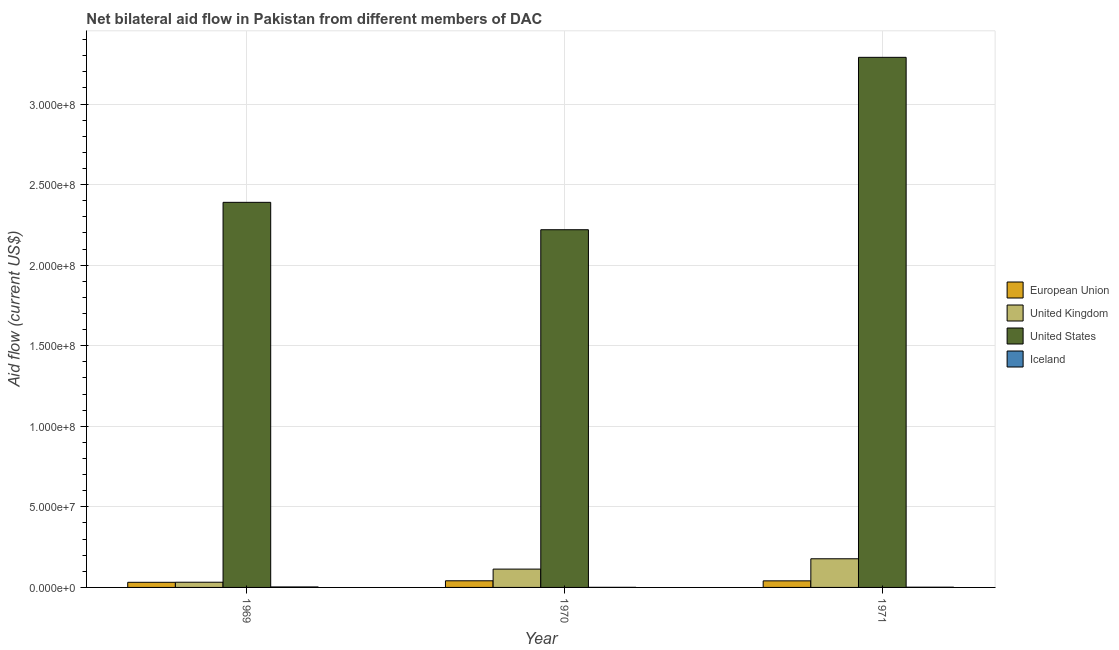How many groups of bars are there?
Offer a terse response. 3. Are the number of bars per tick equal to the number of legend labels?
Your answer should be very brief. Yes. How many bars are there on the 3rd tick from the left?
Give a very brief answer. 4. How many bars are there on the 3rd tick from the right?
Offer a very short reply. 4. What is the label of the 3rd group of bars from the left?
Your response must be concise. 1971. What is the amount of aid given by uk in 1971?
Provide a succinct answer. 1.78e+07. Across all years, what is the maximum amount of aid given by us?
Offer a very short reply. 3.29e+08. Across all years, what is the minimum amount of aid given by eu?
Ensure brevity in your answer.  3.18e+06. In which year was the amount of aid given by uk maximum?
Make the answer very short. 1971. In which year was the amount of aid given by uk minimum?
Keep it short and to the point. 1969. What is the total amount of aid given by us in the graph?
Offer a very short reply. 7.90e+08. What is the difference between the amount of aid given by uk in 1970 and that in 1971?
Provide a succinct answer. -6.41e+06. What is the difference between the amount of aid given by uk in 1971 and the amount of aid given by eu in 1969?
Offer a terse response. 1.46e+07. What is the average amount of aid given by eu per year?
Make the answer very short. 3.79e+06. In the year 1970, what is the difference between the amount of aid given by us and amount of aid given by uk?
Your answer should be compact. 0. What is the ratio of the amount of aid given by uk in 1970 to that in 1971?
Keep it short and to the point. 0.64. Is the amount of aid given by us in 1969 less than that in 1970?
Your answer should be compact. No. Is the difference between the amount of aid given by eu in 1969 and 1971 greater than the difference between the amount of aid given by us in 1969 and 1971?
Offer a terse response. No. What is the difference between the highest and the lowest amount of aid given by uk?
Your answer should be compact. 1.46e+07. In how many years, is the amount of aid given by eu greater than the average amount of aid given by eu taken over all years?
Your response must be concise. 2. Is it the case that in every year, the sum of the amount of aid given by us and amount of aid given by eu is greater than the sum of amount of aid given by uk and amount of aid given by iceland?
Offer a very short reply. Yes. Is it the case that in every year, the sum of the amount of aid given by eu and amount of aid given by uk is greater than the amount of aid given by us?
Your response must be concise. No. How many years are there in the graph?
Offer a very short reply. 3. Does the graph contain any zero values?
Offer a very short reply. No. Does the graph contain grids?
Your answer should be very brief. Yes. Where does the legend appear in the graph?
Provide a succinct answer. Center right. How many legend labels are there?
Offer a very short reply. 4. How are the legend labels stacked?
Provide a short and direct response. Vertical. What is the title of the graph?
Ensure brevity in your answer.  Net bilateral aid flow in Pakistan from different members of DAC. Does "Permission" appear as one of the legend labels in the graph?
Your answer should be very brief. No. What is the label or title of the Y-axis?
Your answer should be very brief. Aid flow (current US$). What is the Aid flow (current US$) of European Union in 1969?
Keep it short and to the point. 3.18e+06. What is the Aid flow (current US$) in United Kingdom in 1969?
Offer a very short reply. 3.23e+06. What is the Aid flow (current US$) in United States in 1969?
Keep it short and to the point. 2.39e+08. What is the Aid flow (current US$) of European Union in 1970?
Your answer should be very brief. 4.12e+06. What is the Aid flow (current US$) of United Kingdom in 1970?
Provide a succinct answer. 1.14e+07. What is the Aid flow (current US$) of United States in 1970?
Your answer should be very brief. 2.22e+08. What is the Aid flow (current US$) in Iceland in 1970?
Provide a succinct answer. 6.00e+04. What is the Aid flow (current US$) in European Union in 1971?
Offer a very short reply. 4.08e+06. What is the Aid flow (current US$) in United Kingdom in 1971?
Offer a very short reply. 1.78e+07. What is the Aid flow (current US$) in United States in 1971?
Provide a short and direct response. 3.29e+08. What is the Aid flow (current US$) of Iceland in 1971?
Provide a short and direct response. 1.40e+05. Across all years, what is the maximum Aid flow (current US$) of European Union?
Make the answer very short. 4.12e+06. Across all years, what is the maximum Aid flow (current US$) in United Kingdom?
Keep it short and to the point. 1.78e+07. Across all years, what is the maximum Aid flow (current US$) in United States?
Ensure brevity in your answer.  3.29e+08. Across all years, what is the maximum Aid flow (current US$) in Iceland?
Your answer should be compact. 3.00e+05. Across all years, what is the minimum Aid flow (current US$) of European Union?
Provide a succinct answer. 3.18e+06. Across all years, what is the minimum Aid flow (current US$) in United Kingdom?
Your response must be concise. 3.23e+06. Across all years, what is the minimum Aid flow (current US$) in United States?
Ensure brevity in your answer.  2.22e+08. Across all years, what is the minimum Aid flow (current US$) of Iceland?
Offer a terse response. 6.00e+04. What is the total Aid flow (current US$) in European Union in the graph?
Provide a succinct answer. 1.14e+07. What is the total Aid flow (current US$) in United Kingdom in the graph?
Your answer should be very brief. 3.24e+07. What is the total Aid flow (current US$) in United States in the graph?
Make the answer very short. 7.90e+08. What is the total Aid flow (current US$) in Iceland in the graph?
Provide a short and direct response. 5.00e+05. What is the difference between the Aid flow (current US$) in European Union in 1969 and that in 1970?
Keep it short and to the point. -9.40e+05. What is the difference between the Aid flow (current US$) of United Kingdom in 1969 and that in 1970?
Provide a short and direct response. -8.14e+06. What is the difference between the Aid flow (current US$) in United States in 1969 and that in 1970?
Provide a short and direct response. 1.70e+07. What is the difference between the Aid flow (current US$) of Iceland in 1969 and that in 1970?
Your response must be concise. 2.40e+05. What is the difference between the Aid flow (current US$) in European Union in 1969 and that in 1971?
Your answer should be compact. -9.00e+05. What is the difference between the Aid flow (current US$) in United Kingdom in 1969 and that in 1971?
Keep it short and to the point. -1.46e+07. What is the difference between the Aid flow (current US$) of United States in 1969 and that in 1971?
Provide a succinct answer. -9.00e+07. What is the difference between the Aid flow (current US$) in Iceland in 1969 and that in 1971?
Offer a terse response. 1.60e+05. What is the difference between the Aid flow (current US$) in United Kingdom in 1970 and that in 1971?
Keep it short and to the point. -6.41e+06. What is the difference between the Aid flow (current US$) of United States in 1970 and that in 1971?
Make the answer very short. -1.07e+08. What is the difference between the Aid flow (current US$) of Iceland in 1970 and that in 1971?
Your response must be concise. -8.00e+04. What is the difference between the Aid flow (current US$) of European Union in 1969 and the Aid flow (current US$) of United Kingdom in 1970?
Keep it short and to the point. -8.19e+06. What is the difference between the Aid flow (current US$) of European Union in 1969 and the Aid flow (current US$) of United States in 1970?
Your response must be concise. -2.19e+08. What is the difference between the Aid flow (current US$) in European Union in 1969 and the Aid flow (current US$) in Iceland in 1970?
Make the answer very short. 3.12e+06. What is the difference between the Aid flow (current US$) of United Kingdom in 1969 and the Aid flow (current US$) of United States in 1970?
Your answer should be very brief. -2.19e+08. What is the difference between the Aid flow (current US$) of United Kingdom in 1969 and the Aid flow (current US$) of Iceland in 1970?
Keep it short and to the point. 3.17e+06. What is the difference between the Aid flow (current US$) in United States in 1969 and the Aid flow (current US$) in Iceland in 1970?
Keep it short and to the point. 2.39e+08. What is the difference between the Aid flow (current US$) in European Union in 1969 and the Aid flow (current US$) in United Kingdom in 1971?
Your answer should be compact. -1.46e+07. What is the difference between the Aid flow (current US$) in European Union in 1969 and the Aid flow (current US$) in United States in 1971?
Your answer should be very brief. -3.26e+08. What is the difference between the Aid flow (current US$) in European Union in 1969 and the Aid flow (current US$) in Iceland in 1971?
Your answer should be compact. 3.04e+06. What is the difference between the Aid flow (current US$) in United Kingdom in 1969 and the Aid flow (current US$) in United States in 1971?
Offer a terse response. -3.26e+08. What is the difference between the Aid flow (current US$) in United Kingdom in 1969 and the Aid flow (current US$) in Iceland in 1971?
Make the answer very short. 3.09e+06. What is the difference between the Aid flow (current US$) of United States in 1969 and the Aid flow (current US$) of Iceland in 1971?
Make the answer very short. 2.39e+08. What is the difference between the Aid flow (current US$) in European Union in 1970 and the Aid flow (current US$) in United Kingdom in 1971?
Keep it short and to the point. -1.37e+07. What is the difference between the Aid flow (current US$) in European Union in 1970 and the Aid flow (current US$) in United States in 1971?
Keep it short and to the point. -3.25e+08. What is the difference between the Aid flow (current US$) of European Union in 1970 and the Aid flow (current US$) of Iceland in 1971?
Your answer should be compact. 3.98e+06. What is the difference between the Aid flow (current US$) of United Kingdom in 1970 and the Aid flow (current US$) of United States in 1971?
Give a very brief answer. -3.18e+08. What is the difference between the Aid flow (current US$) in United Kingdom in 1970 and the Aid flow (current US$) in Iceland in 1971?
Provide a succinct answer. 1.12e+07. What is the difference between the Aid flow (current US$) in United States in 1970 and the Aid flow (current US$) in Iceland in 1971?
Make the answer very short. 2.22e+08. What is the average Aid flow (current US$) in European Union per year?
Offer a terse response. 3.79e+06. What is the average Aid flow (current US$) of United Kingdom per year?
Provide a short and direct response. 1.08e+07. What is the average Aid flow (current US$) in United States per year?
Keep it short and to the point. 2.63e+08. What is the average Aid flow (current US$) in Iceland per year?
Ensure brevity in your answer.  1.67e+05. In the year 1969, what is the difference between the Aid flow (current US$) in European Union and Aid flow (current US$) in United States?
Offer a very short reply. -2.36e+08. In the year 1969, what is the difference between the Aid flow (current US$) of European Union and Aid flow (current US$) of Iceland?
Give a very brief answer. 2.88e+06. In the year 1969, what is the difference between the Aid flow (current US$) of United Kingdom and Aid flow (current US$) of United States?
Provide a succinct answer. -2.36e+08. In the year 1969, what is the difference between the Aid flow (current US$) of United Kingdom and Aid flow (current US$) of Iceland?
Keep it short and to the point. 2.93e+06. In the year 1969, what is the difference between the Aid flow (current US$) in United States and Aid flow (current US$) in Iceland?
Ensure brevity in your answer.  2.39e+08. In the year 1970, what is the difference between the Aid flow (current US$) of European Union and Aid flow (current US$) of United Kingdom?
Provide a succinct answer. -7.25e+06. In the year 1970, what is the difference between the Aid flow (current US$) in European Union and Aid flow (current US$) in United States?
Your response must be concise. -2.18e+08. In the year 1970, what is the difference between the Aid flow (current US$) in European Union and Aid flow (current US$) in Iceland?
Offer a very short reply. 4.06e+06. In the year 1970, what is the difference between the Aid flow (current US$) of United Kingdom and Aid flow (current US$) of United States?
Offer a terse response. -2.11e+08. In the year 1970, what is the difference between the Aid flow (current US$) in United Kingdom and Aid flow (current US$) in Iceland?
Offer a very short reply. 1.13e+07. In the year 1970, what is the difference between the Aid flow (current US$) in United States and Aid flow (current US$) in Iceland?
Your answer should be very brief. 2.22e+08. In the year 1971, what is the difference between the Aid flow (current US$) in European Union and Aid flow (current US$) in United Kingdom?
Ensure brevity in your answer.  -1.37e+07. In the year 1971, what is the difference between the Aid flow (current US$) of European Union and Aid flow (current US$) of United States?
Offer a very short reply. -3.25e+08. In the year 1971, what is the difference between the Aid flow (current US$) of European Union and Aid flow (current US$) of Iceland?
Provide a short and direct response. 3.94e+06. In the year 1971, what is the difference between the Aid flow (current US$) of United Kingdom and Aid flow (current US$) of United States?
Your response must be concise. -3.11e+08. In the year 1971, what is the difference between the Aid flow (current US$) in United Kingdom and Aid flow (current US$) in Iceland?
Your answer should be compact. 1.76e+07. In the year 1971, what is the difference between the Aid flow (current US$) in United States and Aid flow (current US$) in Iceland?
Your response must be concise. 3.29e+08. What is the ratio of the Aid flow (current US$) in European Union in 1969 to that in 1970?
Your response must be concise. 0.77. What is the ratio of the Aid flow (current US$) in United Kingdom in 1969 to that in 1970?
Offer a very short reply. 0.28. What is the ratio of the Aid flow (current US$) in United States in 1969 to that in 1970?
Offer a very short reply. 1.08. What is the ratio of the Aid flow (current US$) of European Union in 1969 to that in 1971?
Ensure brevity in your answer.  0.78. What is the ratio of the Aid flow (current US$) of United Kingdom in 1969 to that in 1971?
Give a very brief answer. 0.18. What is the ratio of the Aid flow (current US$) in United States in 1969 to that in 1971?
Your response must be concise. 0.73. What is the ratio of the Aid flow (current US$) of Iceland in 1969 to that in 1971?
Your answer should be compact. 2.14. What is the ratio of the Aid flow (current US$) of European Union in 1970 to that in 1971?
Your response must be concise. 1.01. What is the ratio of the Aid flow (current US$) in United Kingdom in 1970 to that in 1971?
Offer a terse response. 0.64. What is the ratio of the Aid flow (current US$) in United States in 1970 to that in 1971?
Keep it short and to the point. 0.67. What is the ratio of the Aid flow (current US$) of Iceland in 1970 to that in 1971?
Offer a very short reply. 0.43. What is the difference between the highest and the second highest Aid flow (current US$) of United Kingdom?
Offer a terse response. 6.41e+06. What is the difference between the highest and the second highest Aid flow (current US$) of United States?
Ensure brevity in your answer.  9.00e+07. What is the difference between the highest and the lowest Aid flow (current US$) in European Union?
Your answer should be compact. 9.40e+05. What is the difference between the highest and the lowest Aid flow (current US$) of United Kingdom?
Your answer should be compact. 1.46e+07. What is the difference between the highest and the lowest Aid flow (current US$) in United States?
Make the answer very short. 1.07e+08. What is the difference between the highest and the lowest Aid flow (current US$) in Iceland?
Keep it short and to the point. 2.40e+05. 